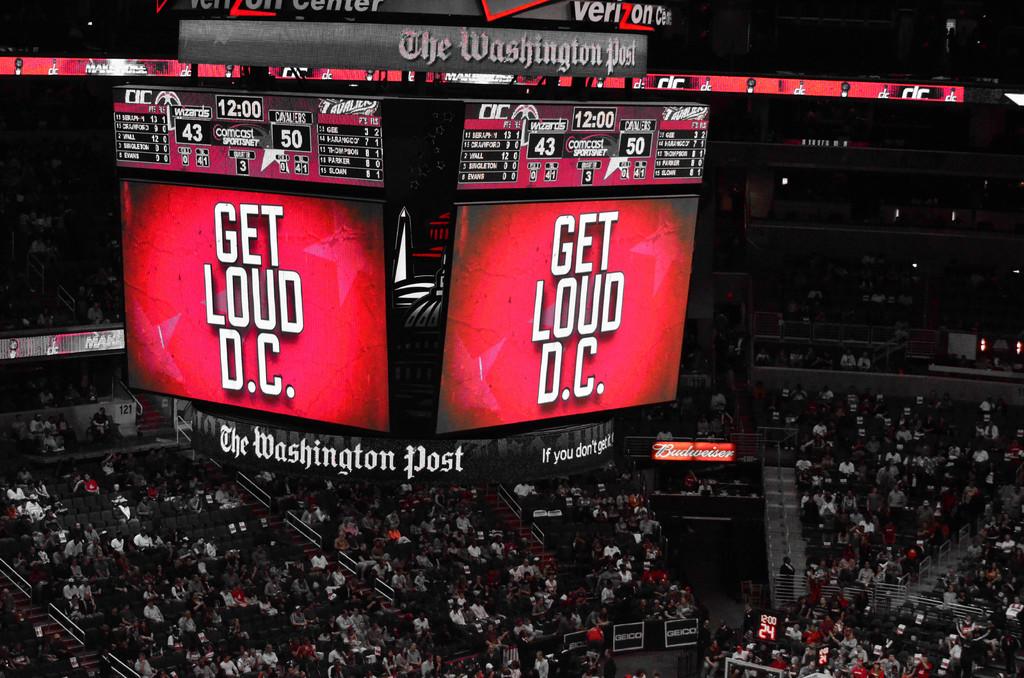Which newspaper sponsors the team?
Make the answer very short. The washington post. 